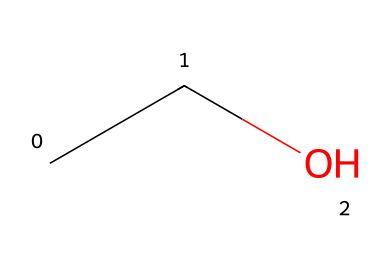What is the name of this chemical? The SMILES representation "CCO" indicates it has two carbon atoms (C) and one oxygen atom (O), which corresponds to ethanol, a common name for this chemical.
Answer: ethanol How many hydrogen atoms are in this molecule? The structure "CCO" shows two carbon atoms, each bonded to three hydrogen atoms, and one oxygen is terminal, which means there are a total of six hydrogen atoms present in the structure: C2H6O.
Answer: six What is the primary functional group in ethanol? In the SMILES "CCO," the presence of the -OH group indicates that it has a hydroxyl functional group, which is characteristic of alcohols.
Answer: hydroxyl Is ethanol a polar solvent? Ethanol contains a hydroxyl group (-OH), which is polar due to the electronegativity difference between oxygen and hydrogen, making ethanol a polar solvent suitable for extracting compounds.
Answer: yes What is the main use of ethanol in culinary herb extraction? Ethanol is used as a solvent in culinary applications primarily due to its ability to dissolve both polar and non-polar compounds, allowing effective extraction of flavors from herbs.
Answer: extraction What distinguishes ethanol from other solvents? Ethanol has a unique ability to mix with water and non-polar solvents, due to its dual nature, making it versatile for extracting a wide range of flavor compounds from various sources, unlike many other solvents.
Answer: versatile How does the chemical structure of ethanol contribute to its solvent properties? The structure "CCO" with its hydroxyl group allows for hydrogen bonding with water and other compounds, enhancing its capability to dissolve different types of substances, thus contributing to its effective solvent properties.
Answer: hydrogen bonding 